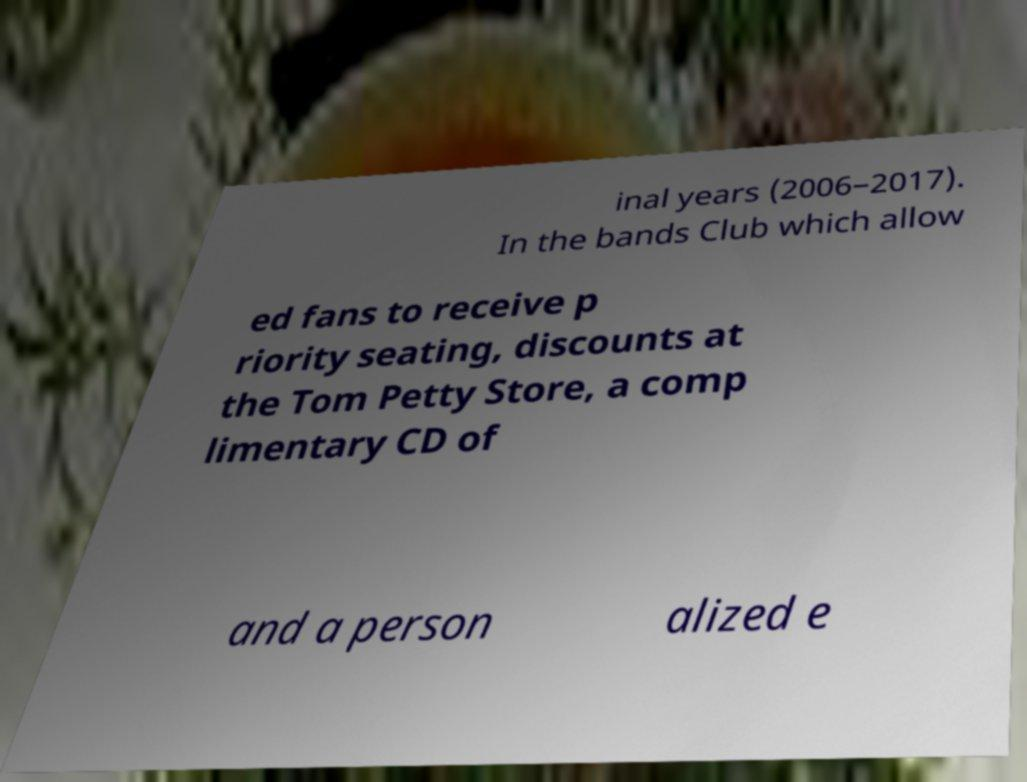Can you read and provide the text displayed in the image?This photo seems to have some interesting text. Can you extract and type it out for me? inal years (2006–2017). In the bands Club which allow ed fans to receive p riority seating, discounts at the Tom Petty Store, a comp limentary CD of and a person alized e 